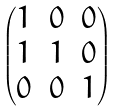<formula> <loc_0><loc_0><loc_500><loc_500>\begin{pmatrix} 1 & 0 & 0 \\ 1 & 1 & 0 \\ 0 & 0 & 1 \end{pmatrix}</formula> 